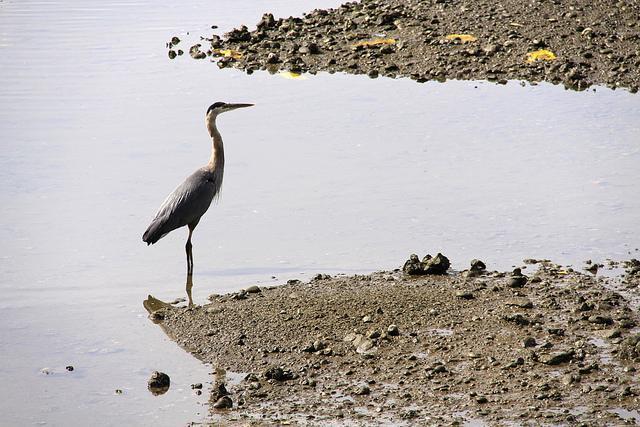How many birds are pictured?
Give a very brief answer. 1. How many buses are there?
Give a very brief answer. 0. 